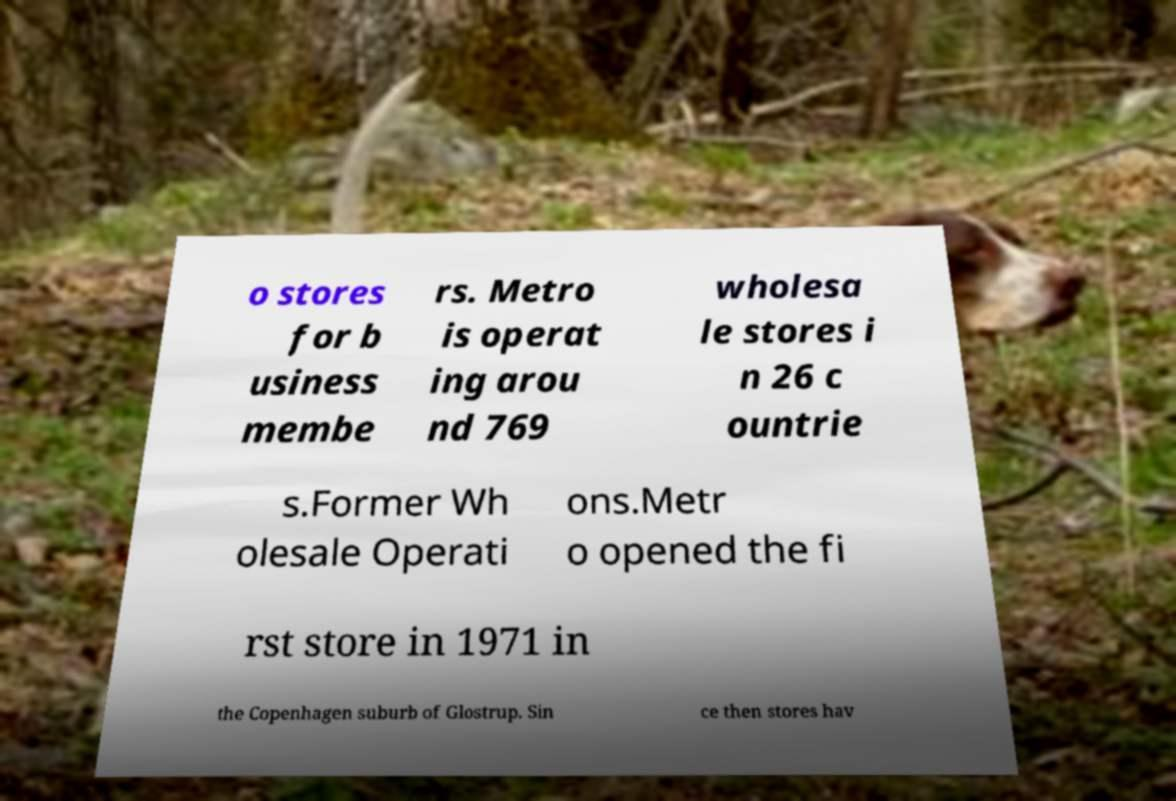Please read and relay the text visible in this image. What does it say? o stores for b usiness membe rs. Metro is operat ing arou nd 769 wholesa le stores i n 26 c ountrie s.Former Wh olesale Operati ons.Metr o opened the fi rst store in 1971 in the Copenhagen suburb of Glostrup. Sin ce then stores hav 